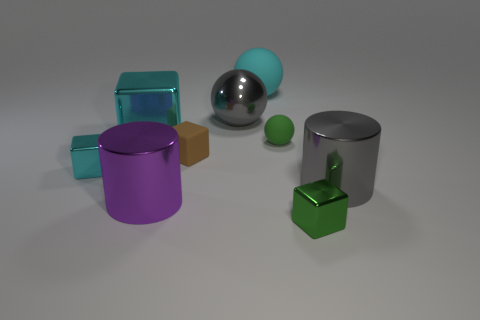There is a sphere to the right of the rubber ball behind the gray sphere; how many large objects are left of it?
Ensure brevity in your answer.  4. What number of shiny things are either big balls or blue cylinders?
Offer a terse response. 1. How big is the gray thing to the left of the large gray metallic thing that is in front of the big cube?
Provide a short and direct response. Large. Do the metallic cube that is right of the large cube and the shiny cylinder to the left of the gray cylinder have the same color?
Offer a terse response. No. There is a large object that is right of the gray sphere and in front of the cyan rubber sphere; what color is it?
Keep it short and to the point. Gray. Is the gray cylinder made of the same material as the tiny cyan thing?
Provide a short and direct response. Yes. What number of large things are either green matte objects or green cubes?
Ensure brevity in your answer.  0. Is there anything else that is the same shape as the cyan rubber thing?
Provide a short and direct response. Yes. There is a tiny sphere that is the same material as the brown cube; what color is it?
Provide a succinct answer. Green. What is the color of the big metallic cylinder on the right side of the small green sphere?
Your answer should be compact. Gray. 